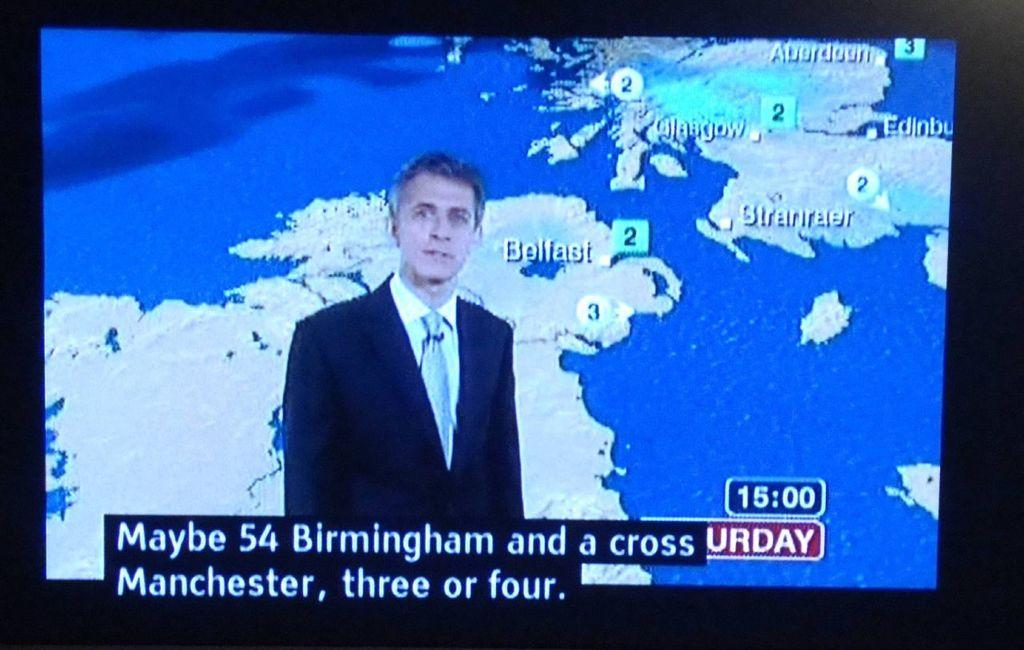<image>
Give a short and clear explanation of the subsequent image. An English weatherman, reporting on cold weather in Birmingham and manchester. 